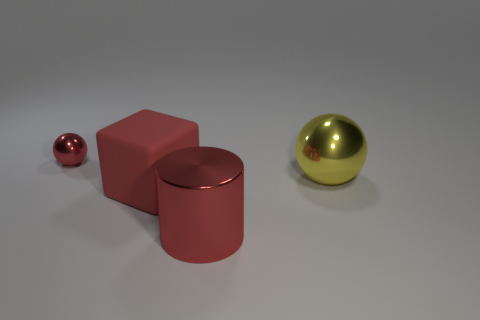Add 4 big metallic things. How many objects exist? 8 Subtract all cylinders. How many objects are left? 3 Add 2 big metallic cylinders. How many big metallic cylinders are left? 3 Add 3 green cubes. How many green cubes exist? 3 Subtract 0 blue spheres. How many objects are left? 4 Subtract all metal things. Subtract all red blocks. How many objects are left? 0 